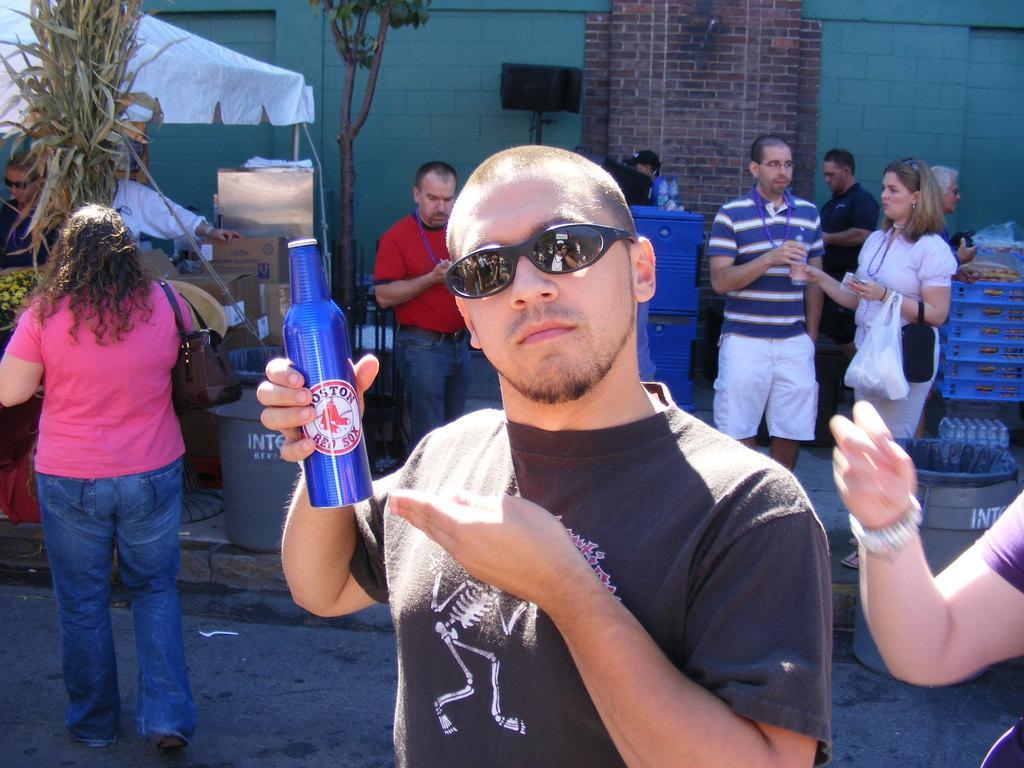Could you give a brief overview of what you see in this image? In this picture I can see a man holding a bottle, there are group of people standing, there are trees, there is a tent, there are cardboard boxes and some other objects, and in the background there is a wall. 